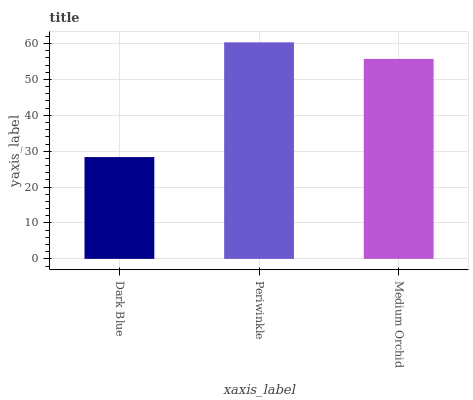Is Medium Orchid the minimum?
Answer yes or no. No. Is Medium Orchid the maximum?
Answer yes or no. No. Is Periwinkle greater than Medium Orchid?
Answer yes or no. Yes. Is Medium Orchid less than Periwinkle?
Answer yes or no. Yes. Is Medium Orchid greater than Periwinkle?
Answer yes or no. No. Is Periwinkle less than Medium Orchid?
Answer yes or no. No. Is Medium Orchid the high median?
Answer yes or no. Yes. Is Medium Orchid the low median?
Answer yes or no. Yes. Is Dark Blue the high median?
Answer yes or no. No. Is Periwinkle the low median?
Answer yes or no. No. 